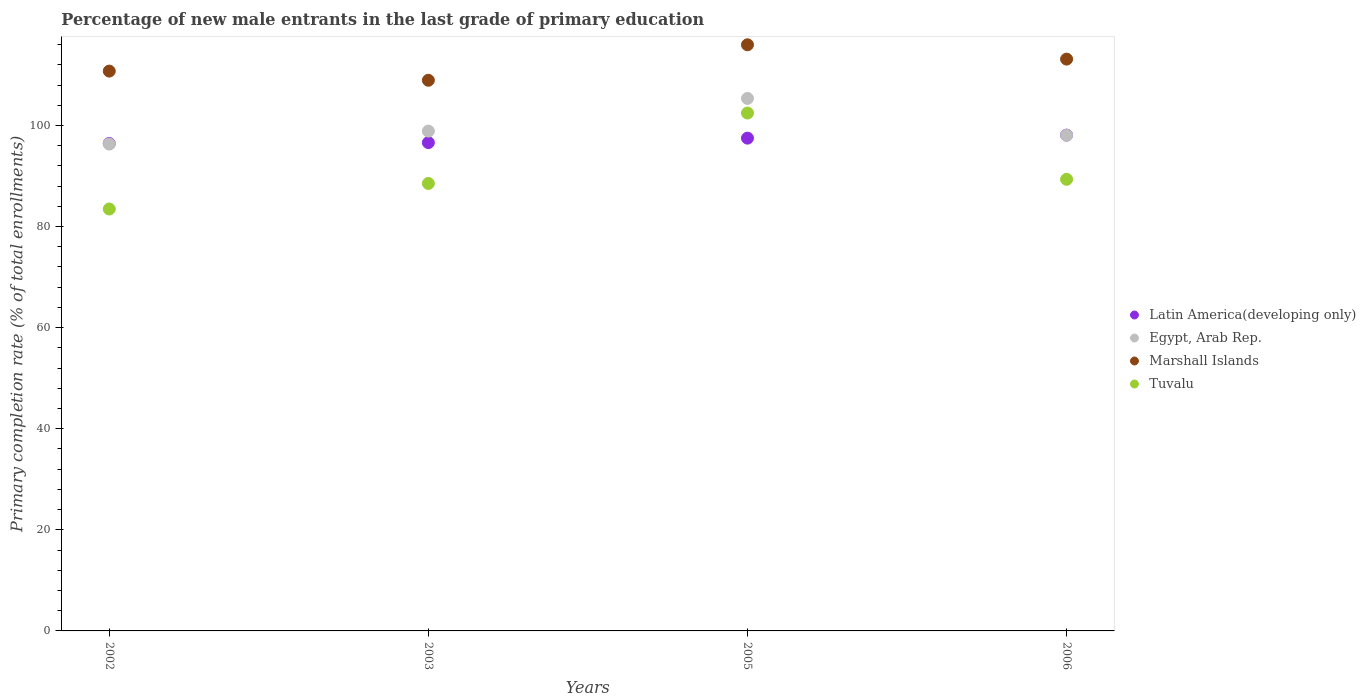What is the percentage of new male entrants in Egypt, Arab Rep. in 2005?
Give a very brief answer. 105.35. Across all years, what is the maximum percentage of new male entrants in Egypt, Arab Rep.?
Your answer should be compact. 105.35. Across all years, what is the minimum percentage of new male entrants in Marshall Islands?
Your answer should be compact. 108.94. In which year was the percentage of new male entrants in Marshall Islands maximum?
Ensure brevity in your answer.  2005. In which year was the percentage of new male entrants in Latin America(developing only) minimum?
Provide a short and direct response. 2002. What is the total percentage of new male entrants in Latin America(developing only) in the graph?
Provide a short and direct response. 388.62. What is the difference between the percentage of new male entrants in Latin America(developing only) in 2002 and that in 2003?
Your answer should be compact. -0.18. What is the difference between the percentage of new male entrants in Latin America(developing only) in 2002 and the percentage of new male entrants in Egypt, Arab Rep. in 2005?
Give a very brief answer. -8.92. What is the average percentage of new male entrants in Latin America(developing only) per year?
Ensure brevity in your answer.  97.16. In the year 2002, what is the difference between the percentage of new male entrants in Marshall Islands and percentage of new male entrants in Tuvalu?
Provide a short and direct response. 27.28. What is the ratio of the percentage of new male entrants in Latin America(developing only) in 2003 to that in 2005?
Give a very brief answer. 0.99. What is the difference between the highest and the second highest percentage of new male entrants in Latin America(developing only)?
Ensure brevity in your answer.  0.6. What is the difference between the highest and the lowest percentage of new male entrants in Latin America(developing only)?
Offer a very short reply. 1.66. Is the sum of the percentage of new male entrants in Latin America(developing only) in 2002 and 2005 greater than the maximum percentage of new male entrants in Marshall Islands across all years?
Give a very brief answer. Yes. Is it the case that in every year, the sum of the percentage of new male entrants in Marshall Islands and percentage of new male entrants in Latin America(developing only)  is greater than the sum of percentage of new male entrants in Egypt, Arab Rep. and percentage of new male entrants in Tuvalu?
Offer a very short reply. Yes. Is it the case that in every year, the sum of the percentage of new male entrants in Tuvalu and percentage of new male entrants in Egypt, Arab Rep.  is greater than the percentage of new male entrants in Marshall Islands?
Keep it short and to the point. Yes. Is the percentage of new male entrants in Marshall Islands strictly greater than the percentage of new male entrants in Egypt, Arab Rep. over the years?
Offer a very short reply. Yes. Is the percentage of new male entrants in Tuvalu strictly less than the percentage of new male entrants in Latin America(developing only) over the years?
Your response must be concise. No. How many dotlines are there?
Keep it short and to the point. 4. How many years are there in the graph?
Make the answer very short. 4. Are the values on the major ticks of Y-axis written in scientific E-notation?
Keep it short and to the point. No. Does the graph contain any zero values?
Offer a very short reply. No. Does the graph contain grids?
Your response must be concise. No. How many legend labels are there?
Ensure brevity in your answer.  4. What is the title of the graph?
Provide a succinct answer. Percentage of new male entrants in the last grade of primary education. Does "Uzbekistan" appear as one of the legend labels in the graph?
Your answer should be compact. No. What is the label or title of the Y-axis?
Provide a succinct answer. Primary completion rate (% of total enrollments). What is the Primary completion rate (% of total enrollments) in Latin America(developing only) in 2002?
Provide a short and direct response. 96.43. What is the Primary completion rate (% of total enrollments) of Egypt, Arab Rep. in 2002?
Make the answer very short. 96.32. What is the Primary completion rate (% of total enrollments) in Marshall Islands in 2002?
Your response must be concise. 110.76. What is the Primary completion rate (% of total enrollments) of Tuvalu in 2002?
Ensure brevity in your answer.  83.47. What is the Primary completion rate (% of total enrollments) of Latin America(developing only) in 2003?
Make the answer very short. 96.61. What is the Primary completion rate (% of total enrollments) of Egypt, Arab Rep. in 2003?
Keep it short and to the point. 98.89. What is the Primary completion rate (% of total enrollments) in Marshall Islands in 2003?
Your answer should be very brief. 108.94. What is the Primary completion rate (% of total enrollments) of Tuvalu in 2003?
Make the answer very short. 88.52. What is the Primary completion rate (% of total enrollments) of Latin America(developing only) in 2005?
Provide a short and direct response. 97.49. What is the Primary completion rate (% of total enrollments) of Egypt, Arab Rep. in 2005?
Your answer should be compact. 105.35. What is the Primary completion rate (% of total enrollments) of Marshall Islands in 2005?
Provide a short and direct response. 115.96. What is the Primary completion rate (% of total enrollments) of Tuvalu in 2005?
Provide a short and direct response. 102.46. What is the Primary completion rate (% of total enrollments) in Latin America(developing only) in 2006?
Offer a terse response. 98.09. What is the Primary completion rate (% of total enrollments) in Egypt, Arab Rep. in 2006?
Give a very brief answer. 98.06. What is the Primary completion rate (% of total enrollments) of Marshall Islands in 2006?
Ensure brevity in your answer.  113.13. What is the Primary completion rate (% of total enrollments) of Tuvalu in 2006?
Offer a very short reply. 89.34. Across all years, what is the maximum Primary completion rate (% of total enrollments) of Latin America(developing only)?
Your answer should be very brief. 98.09. Across all years, what is the maximum Primary completion rate (% of total enrollments) of Egypt, Arab Rep.?
Provide a succinct answer. 105.35. Across all years, what is the maximum Primary completion rate (% of total enrollments) of Marshall Islands?
Make the answer very short. 115.96. Across all years, what is the maximum Primary completion rate (% of total enrollments) in Tuvalu?
Give a very brief answer. 102.46. Across all years, what is the minimum Primary completion rate (% of total enrollments) of Latin America(developing only)?
Ensure brevity in your answer.  96.43. Across all years, what is the minimum Primary completion rate (% of total enrollments) in Egypt, Arab Rep.?
Your answer should be very brief. 96.32. Across all years, what is the minimum Primary completion rate (% of total enrollments) of Marshall Islands?
Your answer should be compact. 108.94. Across all years, what is the minimum Primary completion rate (% of total enrollments) in Tuvalu?
Provide a succinct answer. 83.47. What is the total Primary completion rate (% of total enrollments) in Latin America(developing only) in the graph?
Offer a terse response. 388.62. What is the total Primary completion rate (% of total enrollments) of Egypt, Arab Rep. in the graph?
Offer a very short reply. 398.61. What is the total Primary completion rate (% of total enrollments) in Marshall Islands in the graph?
Offer a terse response. 448.79. What is the total Primary completion rate (% of total enrollments) in Tuvalu in the graph?
Give a very brief answer. 363.8. What is the difference between the Primary completion rate (% of total enrollments) in Latin America(developing only) in 2002 and that in 2003?
Your answer should be compact. -0.18. What is the difference between the Primary completion rate (% of total enrollments) of Egypt, Arab Rep. in 2002 and that in 2003?
Offer a terse response. -2.56. What is the difference between the Primary completion rate (% of total enrollments) in Marshall Islands in 2002 and that in 2003?
Ensure brevity in your answer.  1.81. What is the difference between the Primary completion rate (% of total enrollments) of Tuvalu in 2002 and that in 2003?
Provide a succinct answer. -5.05. What is the difference between the Primary completion rate (% of total enrollments) in Latin America(developing only) in 2002 and that in 2005?
Your response must be concise. -1.06. What is the difference between the Primary completion rate (% of total enrollments) of Egypt, Arab Rep. in 2002 and that in 2005?
Offer a terse response. -9.02. What is the difference between the Primary completion rate (% of total enrollments) in Marshall Islands in 2002 and that in 2005?
Offer a terse response. -5.21. What is the difference between the Primary completion rate (% of total enrollments) of Tuvalu in 2002 and that in 2005?
Give a very brief answer. -18.99. What is the difference between the Primary completion rate (% of total enrollments) in Latin America(developing only) in 2002 and that in 2006?
Provide a succinct answer. -1.66. What is the difference between the Primary completion rate (% of total enrollments) in Egypt, Arab Rep. in 2002 and that in 2006?
Make the answer very short. -1.73. What is the difference between the Primary completion rate (% of total enrollments) in Marshall Islands in 2002 and that in 2006?
Provide a short and direct response. -2.37. What is the difference between the Primary completion rate (% of total enrollments) in Tuvalu in 2002 and that in 2006?
Your answer should be compact. -5.87. What is the difference between the Primary completion rate (% of total enrollments) of Latin America(developing only) in 2003 and that in 2005?
Keep it short and to the point. -0.89. What is the difference between the Primary completion rate (% of total enrollments) of Egypt, Arab Rep. in 2003 and that in 2005?
Provide a succinct answer. -6.46. What is the difference between the Primary completion rate (% of total enrollments) of Marshall Islands in 2003 and that in 2005?
Offer a very short reply. -7.02. What is the difference between the Primary completion rate (% of total enrollments) in Tuvalu in 2003 and that in 2005?
Your response must be concise. -13.93. What is the difference between the Primary completion rate (% of total enrollments) of Latin America(developing only) in 2003 and that in 2006?
Your response must be concise. -1.48. What is the difference between the Primary completion rate (% of total enrollments) of Egypt, Arab Rep. in 2003 and that in 2006?
Make the answer very short. 0.83. What is the difference between the Primary completion rate (% of total enrollments) in Marshall Islands in 2003 and that in 2006?
Offer a very short reply. -4.18. What is the difference between the Primary completion rate (% of total enrollments) in Tuvalu in 2003 and that in 2006?
Offer a very short reply. -0.82. What is the difference between the Primary completion rate (% of total enrollments) in Latin America(developing only) in 2005 and that in 2006?
Ensure brevity in your answer.  -0.6. What is the difference between the Primary completion rate (% of total enrollments) of Egypt, Arab Rep. in 2005 and that in 2006?
Your response must be concise. 7.29. What is the difference between the Primary completion rate (% of total enrollments) in Marshall Islands in 2005 and that in 2006?
Ensure brevity in your answer.  2.83. What is the difference between the Primary completion rate (% of total enrollments) of Tuvalu in 2005 and that in 2006?
Keep it short and to the point. 13.11. What is the difference between the Primary completion rate (% of total enrollments) of Latin America(developing only) in 2002 and the Primary completion rate (% of total enrollments) of Egypt, Arab Rep. in 2003?
Your answer should be very brief. -2.46. What is the difference between the Primary completion rate (% of total enrollments) in Latin America(developing only) in 2002 and the Primary completion rate (% of total enrollments) in Marshall Islands in 2003?
Offer a terse response. -12.51. What is the difference between the Primary completion rate (% of total enrollments) of Latin America(developing only) in 2002 and the Primary completion rate (% of total enrollments) of Tuvalu in 2003?
Keep it short and to the point. 7.91. What is the difference between the Primary completion rate (% of total enrollments) in Egypt, Arab Rep. in 2002 and the Primary completion rate (% of total enrollments) in Marshall Islands in 2003?
Make the answer very short. -12.62. What is the difference between the Primary completion rate (% of total enrollments) in Egypt, Arab Rep. in 2002 and the Primary completion rate (% of total enrollments) in Tuvalu in 2003?
Give a very brief answer. 7.8. What is the difference between the Primary completion rate (% of total enrollments) of Marshall Islands in 2002 and the Primary completion rate (% of total enrollments) of Tuvalu in 2003?
Provide a short and direct response. 22.23. What is the difference between the Primary completion rate (% of total enrollments) of Latin America(developing only) in 2002 and the Primary completion rate (% of total enrollments) of Egypt, Arab Rep. in 2005?
Provide a short and direct response. -8.92. What is the difference between the Primary completion rate (% of total enrollments) in Latin America(developing only) in 2002 and the Primary completion rate (% of total enrollments) in Marshall Islands in 2005?
Your answer should be compact. -19.53. What is the difference between the Primary completion rate (% of total enrollments) in Latin America(developing only) in 2002 and the Primary completion rate (% of total enrollments) in Tuvalu in 2005?
Your response must be concise. -6.03. What is the difference between the Primary completion rate (% of total enrollments) of Egypt, Arab Rep. in 2002 and the Primary completion rate (% of total enrollments) of Marshall Islands in 2005?
Provide a succinct answer. -19.64. What is the difference between the Primary completion rate (% of total enrollments) in Egypt, Arab Rep. in 2002 and the Primary completion rate (% of total enrollments) in Tuvalu in 2005?
Make the answer very short. -6.14. What is the difference between the Primary completion rate (% of total enrollments) in Marshall Islands in 2002 and the Primary completion rate (% of total enrollments) in Tuvalu in 2005?
Give a very brief answer. 8.3. What is the difference between the Primary completion rate (% of total enrollments) in Latin America(developing only) in 2002 and the Primary completion rate (% of total enrollments) in Egypt, Arab Rep. in 2006?
Keep it short and to the point. -1.63. What is the difference between the Primary completion rate (% of total enrollments) in Latin America(developing only) in 2002 and the Primary completion rate (% of total enrollments) in Marshall Islands in 2006?
Offer a terse response. -16.7. What is the difference between the Primary completion rate (% of total enrollments) of Latin America(developing only) in 2002 and the Primary completion rate (% of total enrollments) of Tuvalu in 2006?
Make the answer very short. 7.09. What is the difference between the Primary completion rate (% of total enrollments) in Egypt, Arab Rep. in 2002 and the Primary completion rate (% of total enrollments) in Marshall Islands in 2006?
Offer a terse response. -16.8. What is the difference between the Primary completion rate (% of total enrollments) of Egypt, Arab Rep. in 2002 and the Primary completion rate (% of total enrollments) of Tuvalu in 2006?
Give a very brief answer. 6.98. What is the difference between the Primary completion rate (% of total enrollments) of Marshall Islands in 2002 and the Primary completion rate (% of total enrollments) of Tuvalu in 2006?
Your response must be concise. 21.41. What is the difference between the Primary completion rate (% of total enrollments) of Latin America(developing only) in 2003 and the Primary completion rate (% of total enrollments) of Egypt, Arab Rep. in 2005?
Offer a terse response. -8.74. What is the difference between the Primary completion rate (% of total enrollments) in Latin America(developing only) in 2003 and the Primary completion rate (% of total enrollments) in Marshall Islands in 2005?
Your response must be concise. -19.35. What is the difference between the Primary completion rate (% of total enrollments) in Latin America(developing only) in 2003 and the Primary completion rate (% of total enrollments) in Tuvalu in 2005?
Your answer should be compact. -5.85. What is the difference between the Primary completion rate (% of total enrollments) in Egypt, Arab Rep. in 2003 and the Primary completion rate (% of total enrollments) in Marshall Islands in 2005?
Give a very brief answer. -17.08. What is the difference between the Primary completion rate (% of total enrollments) in Egypt, Arab Rep. in 2003 and the Primary completion rate (% of total enrollments) in Tuvalu in 2005?
Keep it short and to the point. -3.57. What is the difference between the Primary completion rate (% of total enrollments) of Marshall Islands in 2003 and the Primary completion rate (% of total enrollments) of Tuvalu in 2005?
Offer a very short reply. 6.48. What is the difference between the Primary completion rate (% of total enrollments) in Latin America(developing only) in 2003 and the Primary completion rate (% of total enrollments) in Egypt, Arab Rep. in 2006?
Your response must be concise. -1.45. What is the difference between the Primary completion rate (% of total enrollments) of Latin America(developing only) in 2003 and the Primary completion rate (% of total enrollments) of Marshall Islands in 2006?
Offer a terse response. -16.52. What is the difference between the Primary completion rate (% of total enrollments) in Latin America(developing only) in 2003 and the Primary completion rate (% of total enrollments) in Tuvalu in 2006?
Your response must be concise. 7.26. What is the difference between the Primary completion rate (% of total enrollments) of Egypt, Arab Rep. in 2003 and the Primary completion rate (% of total enrollments) of Marshall Islands in 2006?
Offer a very short reply. -14.24. What is the difference between the Primary completion rate (% of total enrollments) of Egypt, Arab Rep. in 2003 and the Primary completion rate (% of total enrollments) of Tuvalu in 2006?
Provide a succinct answer. 9.54. What is the difference between the Primary completion rate (% of total enrollments) of Marshall Islands in 2003 and the Primary completion rate (% of total enrollments) of Tuvalu in 2006?
Keep it short and to the point. 19.6. What is the difference between the Primary completion rate (% of total enrollments) in Latin America(developing only) in 2005 and the Primary completion rate (% of total enrollments) in Egypt, Arab Rep. in 2006?
Provide a short and direct response. -0.56. What is the difference between the Primary completion rate (% of total enrollments) of Latin America(developing only) in 2005 and the Primary completion rate (% of total enrollments) of Marshall Islands in 2006?
Your response must be concise. -15.63. What is the difference between the Primary completion rate (% of total enrollments) of Latin America(developing only) in 2005 and the Primary completion rate (% of total enrollments) of Tuvalu in 2006?
Make the answer very short. 8.15. What is the difference between the Primary completion rate (% of total enrollments) of Egypt, Arab Rep. in 2005 and the Primary completion rate (% of total enrollments) of Marshall Islands in 2006?
Your response must be concise. -7.78. What is the difference between the Primary completion rate (% of total enrollments) of Egypt, Arab Rep. in 2005 and the Primary completion rate (% of total enrollments) of Tuvalu in 2006?
Provide a short and direct response. 16. What is the difference between the Primary completion rate (% of total enrollments) of Marshall Islands in 2005 and the Primary completion rate (% of total enrollments) of Tuvalu in 2006?
Offer a terse response. 26.62. What is the average Primary completion rate (% of total enrollments) of Latin America(developing only) per year?
Give a very brief answer. 97.16. What is the average Primary completion rate (% of total enrollments) of Egypt, Arab Rep. per year?
Your answer should be very brief. 99.65. What is the average Primary completion rate (% of total enrollments) in Marshall Islands per year?
Make the answer very short. 112.2. What is the average Primary completion rate (% of total enrollments) of Tuvalu per year?
Give a very brief answer. 90.95. In the year 2002, what is the difference between the Primary completion rate (% of total enrollments) in Latin America(developing only) and Primary completion rate (% of total enrollments) in Egypt, Arab Rep.?
Your answer should be compact. 0.11. In the year 2002, what is the difference between the Primary completion rate (% of total enrollments) in Latin America(developing only) and Primary completion rate (% of total enrollments) in Marshall Islands?
Your response must be concise. -14.33. In the year 2002, what is the difference between the Primary completion rate (% of total enrollments) of Latin America(developing only) and Primary completion rate (% of total enrollments) of Tuvalu?
Provide a succinct answer. 12.96. In the year 2002, what is the difference between the Primary completion rate (% of total enrollments) of Egypt, Arab Rep. and Primary completion rate (% of total enrollments) of Marshall Islands?
Ensure brevity in your answer.  -14.43. In the year 2002, what is the difference between the Primary completion rate (% of total enrollments) of Egypt, Arab Rep. and Primary completion rate (% of total enrollments) of Tuvalu?
Your answer should be very brief. 12.85. In the year 2002, what is the difference between the Primary completion rate (% of total enrollments) in Marshall Islands and Primary completion rate (% of total enrollments) in Tuvalu?
Provide a succinct answer. 27.28. In the year 2003, what is the difference between the Primary completion rate (% of total enrollments) of Latin America(developing only) and Primary completion rate (% of total enrollments) of Egypt, Arab Rep.?
Make the answer very short. -2.28. In the year 2003, what is the difference between the Primary completion rate (% of total enrollments) in Latin America(developing only) and Primary completion rate (% of total enrollments) in Marshall Islands?
Your answer should be very brief. -12.34. In the year 2003, what is the difference between the Primary completion rate (% of total enrollments) of Latin America(developing only) and Primary completion rate (% of total enrollments) of Tuvalu?
Your answer should be compact. 8.08. In the year 2003, what is the difference between the Primary completion rate (% of total enrollments) in Egypt, Arab Rep. and Primary completion rate (% of total enrollments) in Marshall Islands?
Give a very brief answer. -10.06. In the year 2003, what is the difference between the Primary completion rate (% of total enrollments) in Egypt, Arab Rep. and Primary completion rate (% of total enrollments) in Tuvalu?
Offer a terse response. 10.36. In the year 2003, what is the difference between the Primary completion rate (% of total enrollments) in Marshall Islands and Primary completion rate (% of total enrollments) in Tuvalu?
Make the answer very short. 20.42. In the year 2005, what is the difference between the Primary completion rate (% of total enrollments) in Latin America(developing only) and Primary completion rate (% of total enrollments) in Egypt, Arab Rep.?
Your answer should be very brief. -7.85. In the year 2005, what is the difference between the Primary completion rate (% of total enrollments) in Latin America(developing only) and Primary completion rate (% of total enrollments) in Marshall Islands?
Provide a succinct answer. -18.47. In the year 2005, what is the difference between the Primary completion rate (% of total enrollments) of Latin America(developing only) and Primary completion rate (% of total enrollments) of Tuvalu?
Ensure brevity in your answer.  -4.97. In the year 2005, what is the difference between the Primary completion rate (% of total enrollments) in Egypt, Arab Rep. and Primary completion rate (% of total enrollments) in Marshall Islands?
Provide a short and direct response. -10.61. In the year 2005, what is the difference between the Primary completion rate (% of total enrollments) in Egypt, Arab Rep. and Primary completion rate (% of total enrollments) in Tuvalu?
Your answer should be compact. 2.89. In the year 2005, what is the difference between the Primary completion rate (% of total enrollments) of Marshall Islands and Primary completion rate (% of total enrollments) of Tuvalu?
Your answer should be very brief. 13.5. In the year 2006, what is the difference between the Primary completion rate (% of total enrollments) of Latin America(developing only) and Primary completion rate (% of total enrollments) of Egypt, Arab Rep.?
Your answer should be compact. 0.03. In the year 2006, what is the difference between the Primary completion rate (% of total enrollments) of Latin America(developing only) and Primary completion rate (% of total enrollments) of Marshall Islands?
Provide a succinct answer. -15.04. In the year 2006, what is the difference between the Primary completion rate (% of total enrollments) in Latin America(developing only) and Primary completion rate (% of total enrollments) in Tuvalu?
Your answer should be compact. 8.75. In the year 2006, what is the difference between the Primary completion rate (% of total enrollments) in Egypt, Arab Rep. and Primary completion rate (% of total enrollments) in Marshall Islands?
Your response must be concise. -15.07. In the year 2006, what is the difference between the Primary completion rate (% of total enrollments) in Egypt, Arab Rep. and Primary completion rate (% of total enrollments) in Tuvalu?
Make the answer very short. 8.71. In the year 2006, what is the difference between the Primary completion rate (% of total enrollments) in Marshall Islands and Primary completion rate (% of total enrollments) in Tuvalu?
Offer a terse response. 23.78. What is the ratio of the Primary completion rate (% of total enrollments) of Egypt, Arab Rep. in 2002 to that in 2003?
Provide a short and direct response. 0.97. What is the ratio of the Primary completion rate (% of total enrollments) of Marshall Islands in 2002 to that in 2003?
Provide a short and direct response. 1.02. What is the ratio of the Primary completion rate (% of total enrollments) in Tuvalu in 2002 to that in 2003?
Your answer should be very brief. 0.94. What is the ratio of the Primary completion rate (% of total enrollments) in Egypt, Arab Rep. in 2002 to that in 2005?
Your answer should be very brief. 0.91. What is the ratio of the Primary completion rate (% of total enrollments) in Marshall Islands in 2002 to that in 2005?
Give a very brief answer. 0.96. What is the ratio of the Primary completion rate (% of total enrollments) in Tuvalu in 2002 to that in 2005?
Keep it short and to the point. 0.81. What is the ratio of the Primary completion rate (% of total enrollments) of Latin America(developing only) in 2002 to that in 2006?
Your answer should be compact. 0.98. What is the ratio of the Primary completion rate (% of total enrollments) in Egypt, Arab Rep. in 2002 to that in 2006?
Ensure brevity in your answer.  0.98. What is the ratio of the Primary completion rate (% of total enrollments) in Marshall Islands in 2002 to that in 2006?
Make the answer very short. 0.98. What is the ratio of the Primary completion rate (% of total enrollments) in Tuvalu in 2002 to that in 2006?
Your response must be concise. 0.93. What is the ratio of the Primary completion rate (% of total enrollments) of Latin America(developing only) in 2003 to that in 2005?
Your answer should be very brief. 0.99. What is the ratio of the Primary completion rate (% of total enrollments) of Egypt, Arab Rep. in 2003 to that in 2005?
Keep it short and to the point. 0.94. What is the ratio of the Primary completion rate (% of total enrollments) in Marshall Islands in 2003 to that in 2005?
Your answer should be compact. 0.94. What is the ratio of the Primary completion rate (% of total enrollments) of Tuvalu in 2003 to that in 2005?
Your answer should be compact. 0.86. What is the ratio of the Primary completion rate (% of total enrollments) in Latin America(developing only) in 2003 to that in 2006?
Your answer should be compact. 0.98. What is the ratio of the Primary completion rate (% of total enrollments) of Egypt, Arab Rep. in 2003 to that in 2006?
Give a very brief answer. 1.01. What is the ratio of the Primary completion rate (% of total enrollments) in Marshall Islands in 2003 to that in 2006?
Your response must be concise. 0.96. What is the ratio of the Primary completion rate (% of total enrollments) of Tuvalu in 2003 to that in 2006?
Your answer should be compact. 0.99. What is the ratio of the Primary completion rate (% of total enrollments) in Egypt, Arab Rep. in 2005 to that in 2006?
Ensure brevity in your answer.  1.07. What is the ratio of the Primary completion rate (% of total enrollments) of Marshall Islands in 2005 to that in 2006?
Offer a terse response. 1.03. What is the ratio of the Primary completion rate (% of total enrollments) of Tuvalu in 2005 to that in 2006?
Your answer should be very brief. 1.15. What is the difference between the highest and the second highest Primary completion rate (% of total enrollments) in Latin America(developing only)?
Provide a short and direct response. 0.6. What is the difference between the highest and the second highest Primary completion rate (% of total enrollments) of Egypt, Arab Rep.?
Your answer should be compact. 6.46. What is the difference between the highest and the second highest Primary completion rate (% of total enrollments) in Marshall Islands?
Your response must be concise. 2.83. What is the difference between the highest and the second highest Primary completion rate (% of total enrollments) of Tuvalu?
Provide a succinct answer. 13.11. What is the difference between the highest and the lowest Primary completion rate (% of total enrollments) of Latin America(developing only)?
Offer a terse response. 1.66. What is the difference between the highest and the lowest Primary completion rate (% of total enrollments) of Egypt, Arab Rep.?
Your response must be concise. 9.02. What is the difference between the highest and the lowest Primary completion rate (% of total enrollments) of Marshall Islands?
Your response must be concise. 7.02. What is the difference between the highest and the lowest Primary completion rate (% of total enrollments) in Tuvalu?
Your response must be concise. 18.99. 